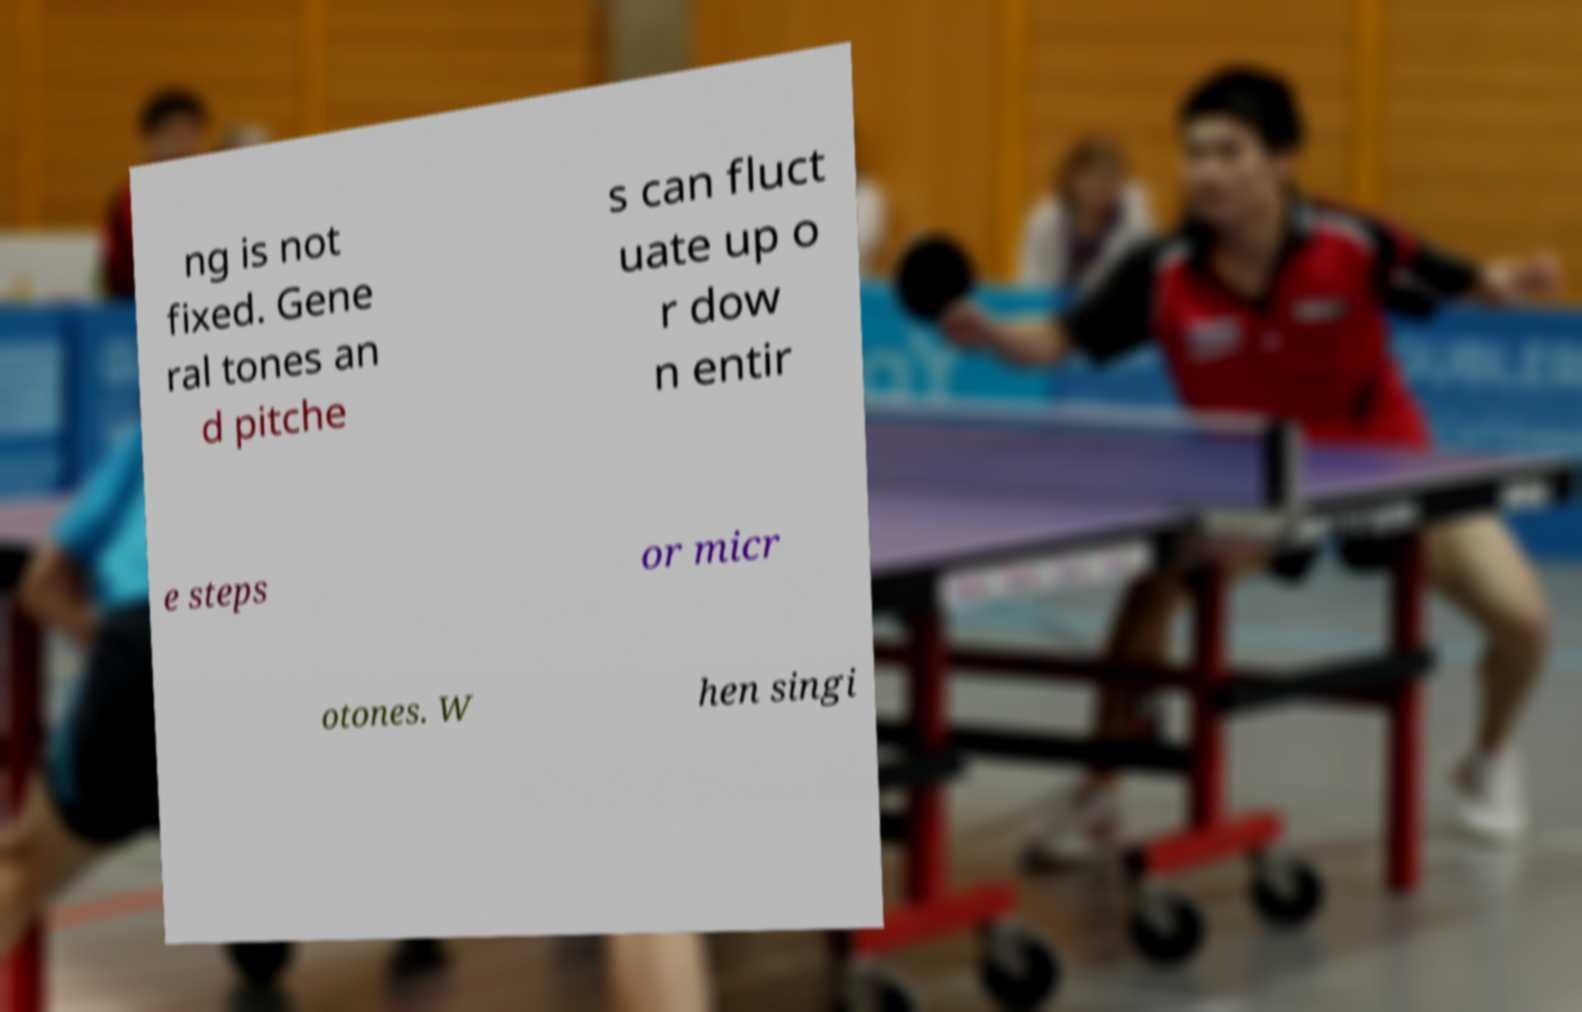Can you accurately transcribe the text from the provided image for me? ng is not fixed. Gene ral tones an d pitche s can fluct uate up o r dow n entir e steps or micr otones. W hen singi 